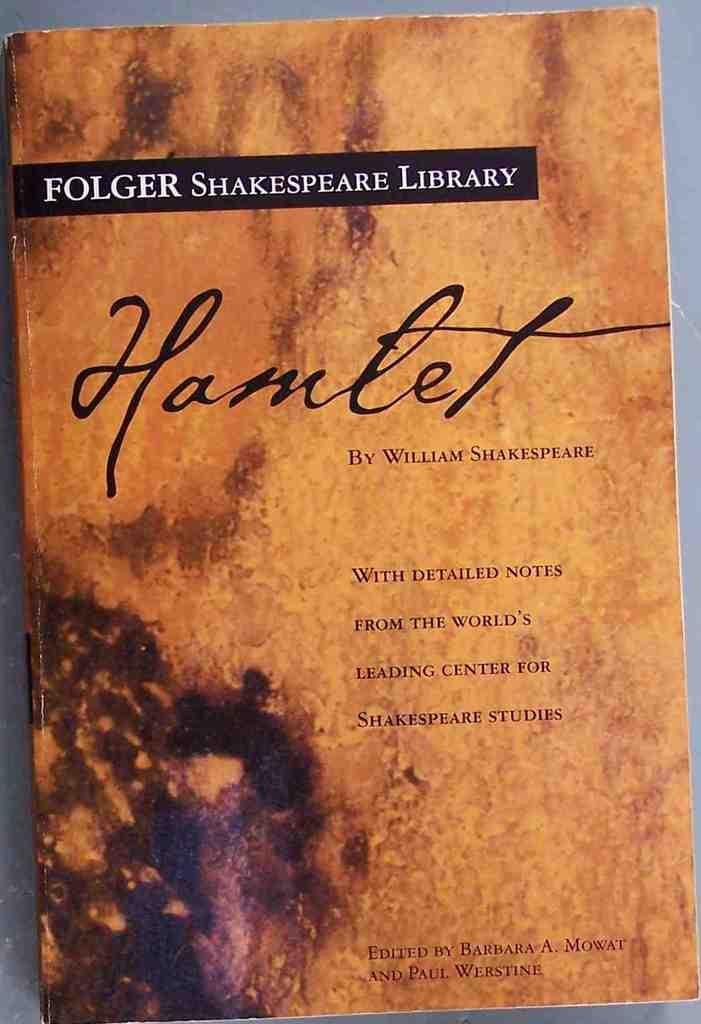<image>
Provide a brief description of the given image. A book cover of Hamlet by Shakespeare has an orange cover. 